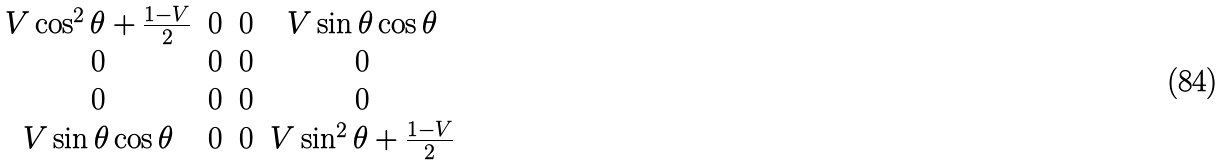<formula> <loc_0><loc_0><loc_500><loc_500>\begin{matrix} V \cos ^ { 2 } \theta + \frac { 1 - V } { 2 } & 0 & 0 & V \sin \theta \cos \theta \\ 0 & 0 & 0 & 0 \\ 0 & 0 & 0 & 0 \\ V \sin \theta \cos \theta & 0 & 0 & V \sin ^ { 2 } \theta + \frac { 1 - V } { 2 } \end{matrix}</formula> 